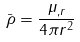<formula> <loc_0><loc_0><loc_500><loc_500>\bar { \rho } = \frac { \mu _ { , r } } { 4 \pi r ^ { 2 } }</formula> 